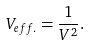<formula> <loc_0><loc_0><loc_500><loc_500>V _ { e f f . } = \frac { 1 } { V ^ { 2 } } .</formula> 